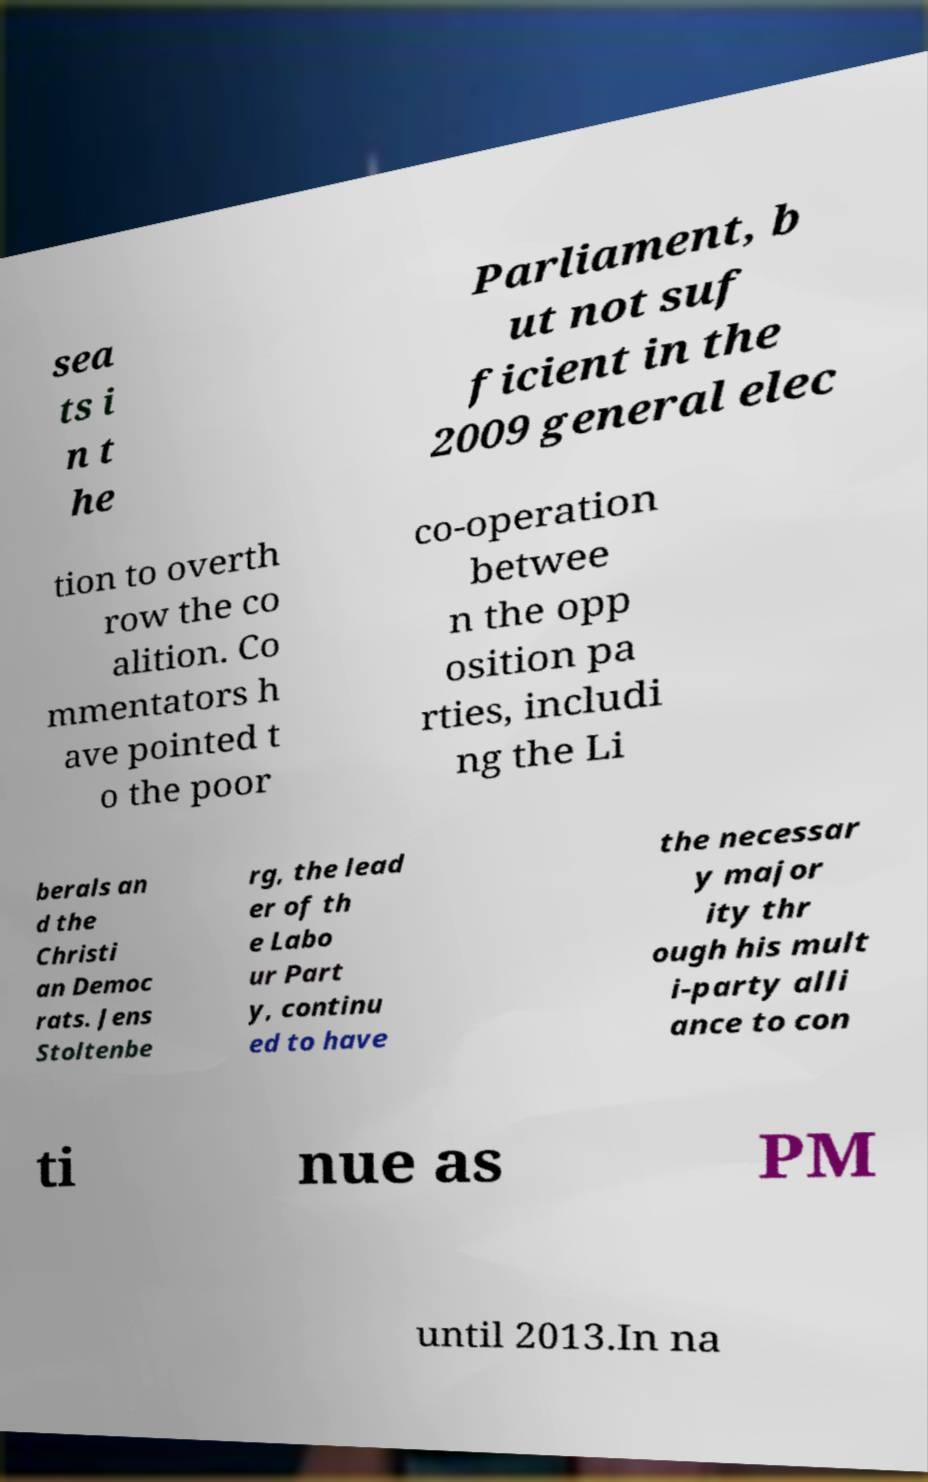I need the written content from this picture converted into text. Can you do that? sea ts i n t he Parliament, b ut not suf ficient in the 2009 general elec tion to overth row the co alition. Co mmentators h ave pointed t o the poor co-operation betwee n the opp osition pa rties, includi ng the Li berals an d the Christi an Democ rats. Jens Stoltenbe rg, the lead er of th e Labo ur Part y, continu ed to have the necessar y major ity thr ough his mult i-party alli ance to con ti nue as PM until 2013.In na 